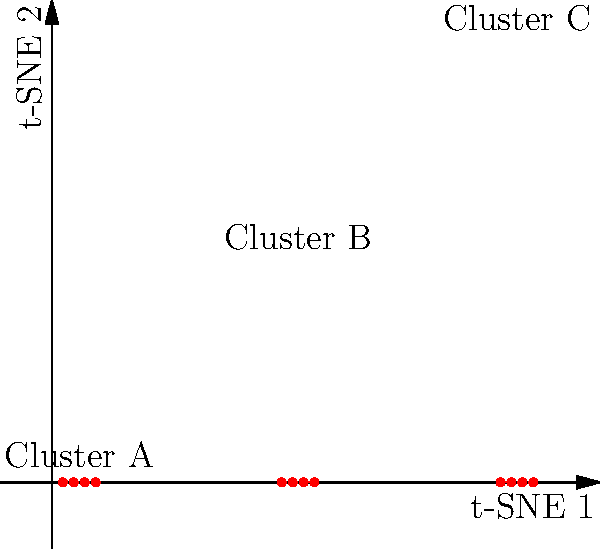In the t-SNE visualization above, three distinct clusters (A, B, and C) are shown. What can be inferred about the original high-dimensional data based on this 2D representation? To interpret this t-SNE visualization and infer information about the original high-dimensional data, let's follow these steps:

1. Understand t-SNE: t-SNE (t-distributed Stochastic Neighbor Embedding) is a dimensionality reduction technique that preserves local relationships between data points while projecting them onto a lower-dimensional space (in this case, 2D).

2. Observe cluster formation: The visualization shows three distinct clusters (A, B, and C), which are well-separated in the 2D space.

3. Interpret cluster separation:
   a. The clear separation between clusters suggests that in the original high-dimensional space, these data points were also distinctly grouped.
   b. Points within each cluster are closer to each other than to points in other clusters, indicating similarity in the original space.

4. Analyze cluster density: All three clusters appear to have similar density and size, suggesting that the original data may have had a balanced distribution among these groups.

5. Consider relative distances: The distances between clusters in t-SNE are not directly proportional to distances in the original space. However, we can infer that Cluster B is likely "between" Clusters A and C in some feature dimensions of the original data.

6. Limitations: Remember that t-SNE focuses on preserving local structures, so global relationships (like overall distances between clusters) may not be accurately represented.

Based on these observations, we can infer that the original high-dimensional data likely contained three distinct groups of points with similar features within each group, but differing features between groups. The original data probably had clear boundaries between these groups in the high-dimensional space.
Answer: The original data likely contained three distinct, well-separated groups with similar within-group features but differing between-group features. 